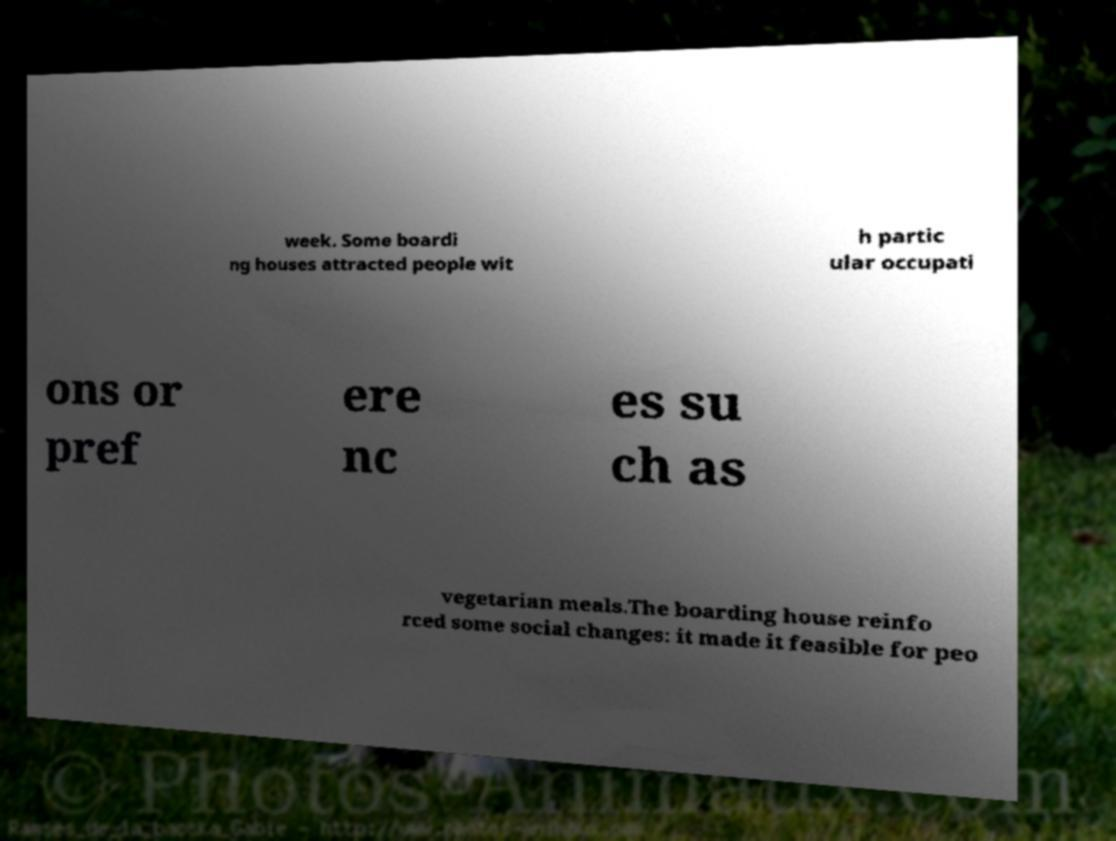Could you extract and type out the text from this image? week. Some boardi ng houses attracted people wit h partic ular occupati ons or pref ere nc es su ch as vegetarian meals.The boarding house reinfo rced some social changes: it made it feasible for peo 